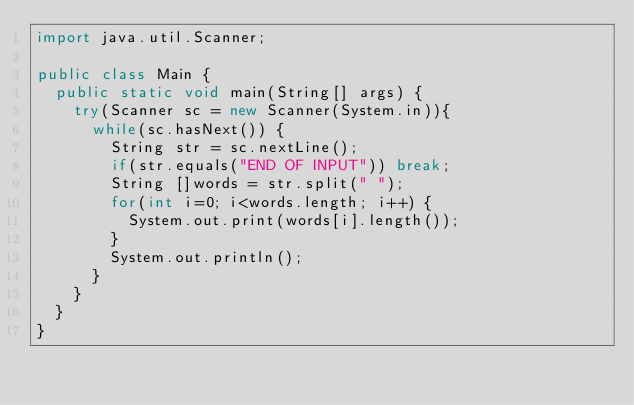Convert code to text. <code><loc_0><loc_0><loc_500><loc_500><_Java_>import java.util.Scanner;

public class Main {
	public static void main(String[] args) {
		try(Scanner sc = new Scanner(System.in)){
			while(sc.hasNext()) {
				String str = sc.nextLine();
				if(str.equals("END OF INPUT")) break;
				String []words = str.split(" ");
				for(int i=0; i<words.length; i++) {
					System.out.print(words[i].length());
				}
				System.out.println();
			}
		}
	}
}
</code> 